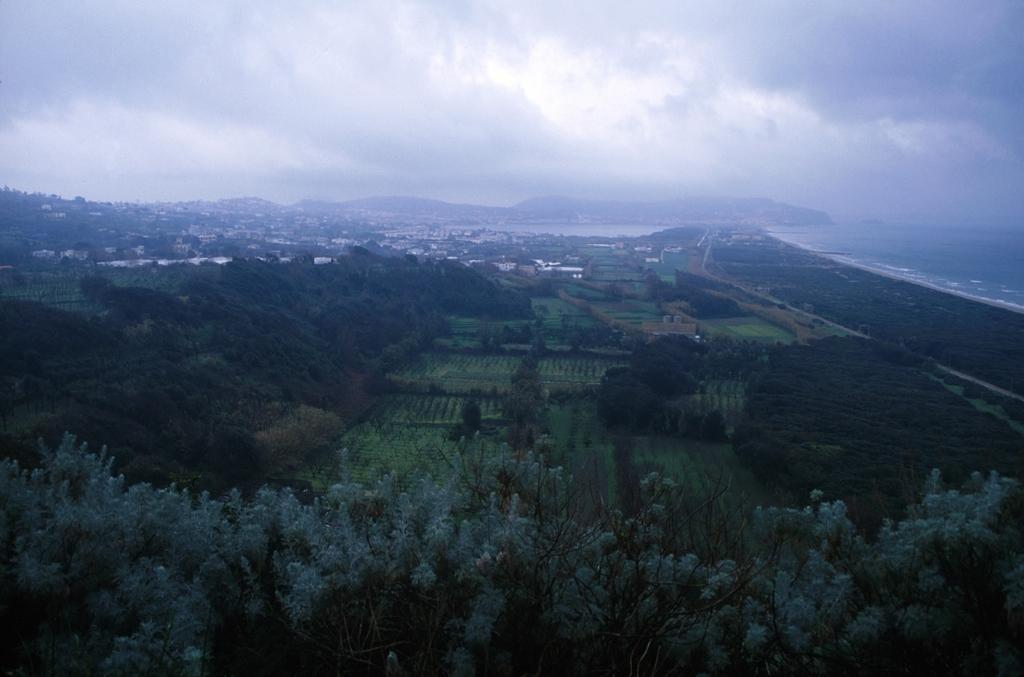How would you summarize this image in a sentence or two? In this image we can see some trees, land and in the background of the image there are some houses, mountains and cloudy sky, on right side of the image there is water. 